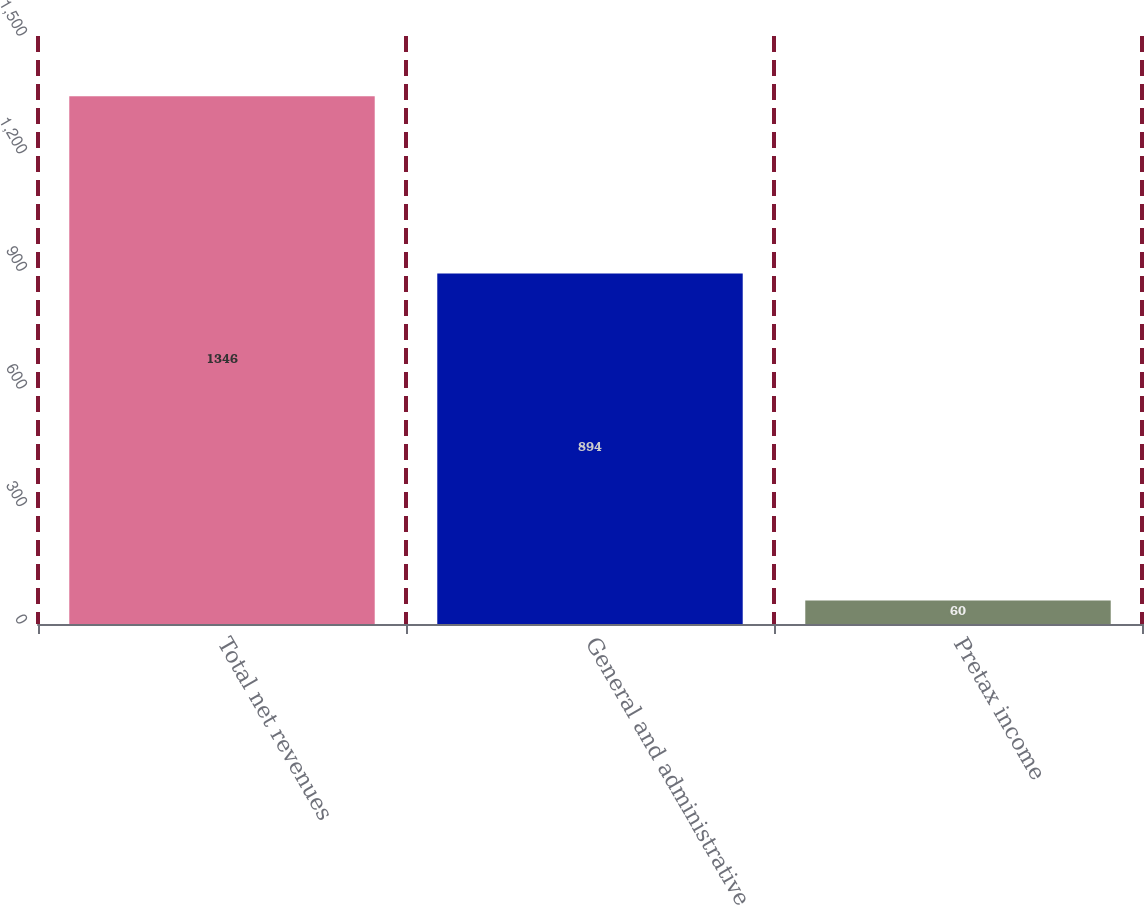<chart> <loc_0><loc_0><loc_500><loc_500><bar_chart><fcel>Total net revenues<fcel>General and administrative<fcel>Pretax income<nl><fcel>1346<fcel>894<fcel>60<nl></chart> 